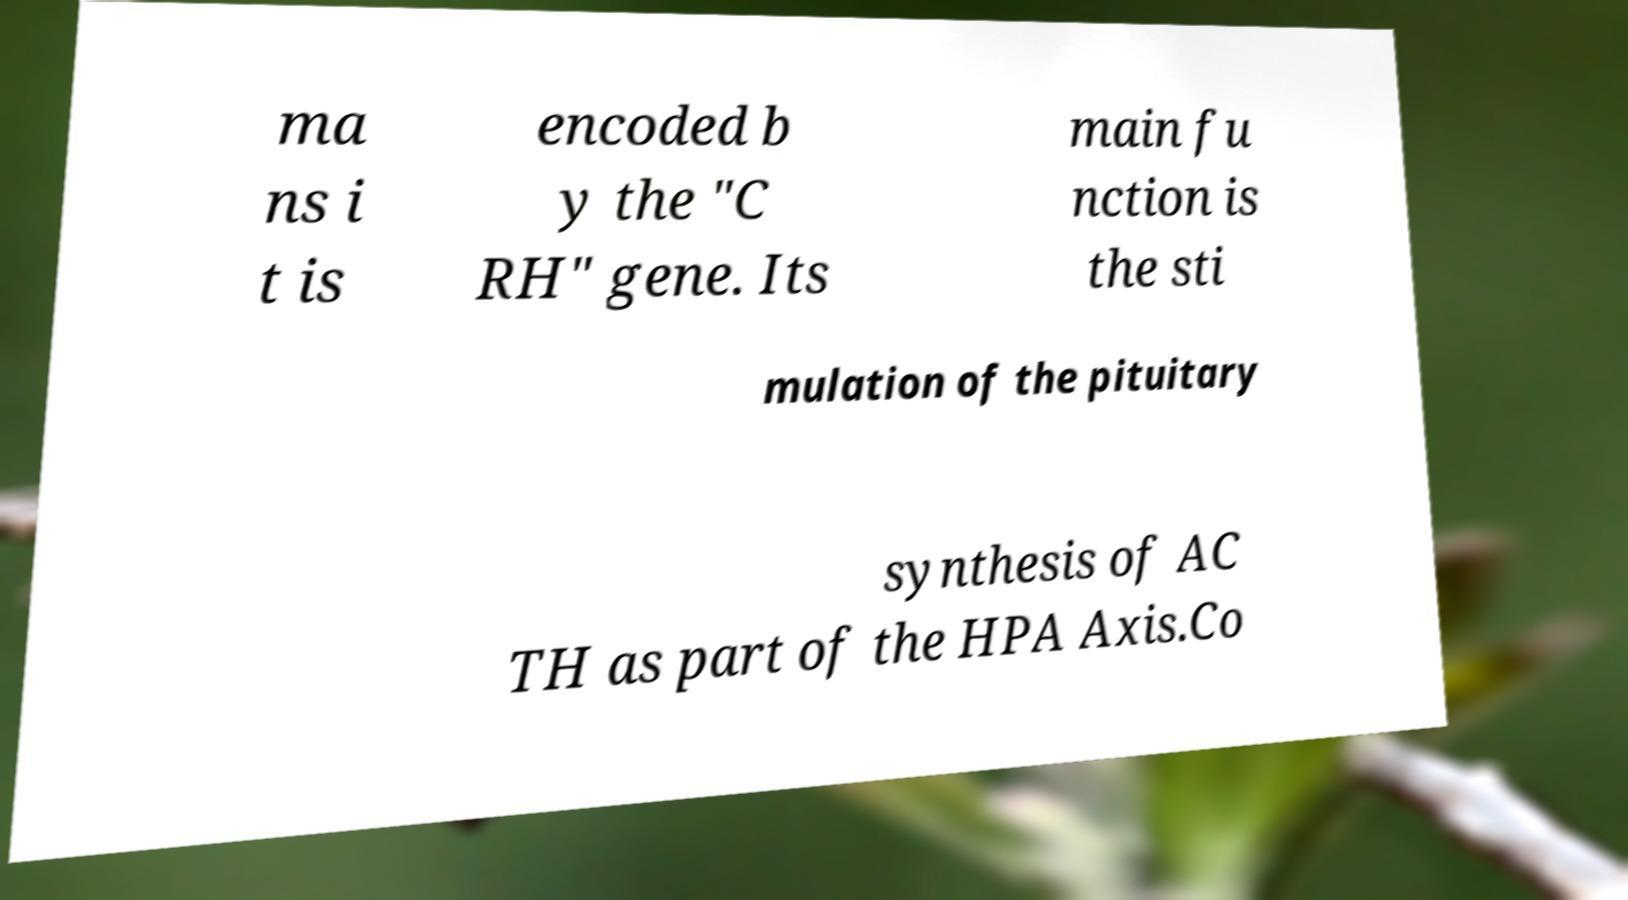What messages or text are displayed in this image? I need them in a readable, typed format. ma ns i t is encoded b y the "C RH" gene. Its main fu nction is the sti mulation of the pituitary synthesis of AC TH as part of the HPA Axis.Co 